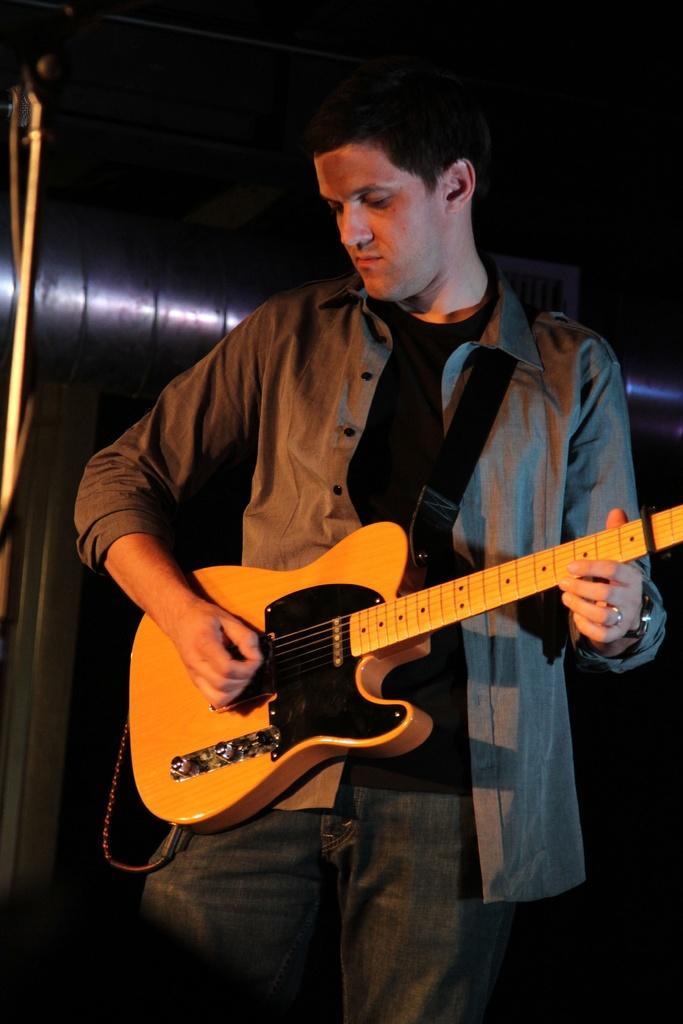In one or two sentences, can you explain what this image depicts? In this picture we can see man holding guitar in his hand and playing and in the background we can see pipe, stand and blur. 